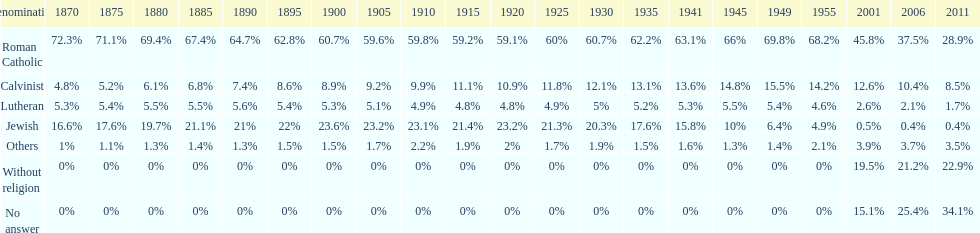What is the biggest religious sect in budapest? Roman Catholic. 